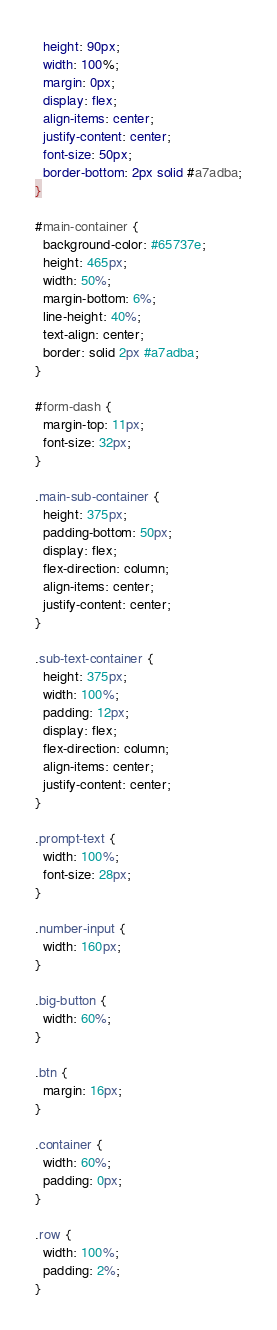Convert code to text. <code><loc_0><loc_0><loc_500><loc_500><_CSS_>  height: 90px;
  width: 100%;
  margin: 0px;
  display: flex;
  align-items: center;
  justify-content: center;
  font-size: 50px;
  border-bottom: 2px solid #a7adba;
}

#main-container {
  background-color: #65737e;
  height: 465px;
  width: 50%;
  margin-bottom: 6%;
  line-height: 40%;
  text-align: center;
  border: solid 2px #a7adba;
}

#form-dash {
  margin-top: 11px;
  font-size: 32px;
}

.main-sub-container {
  height: 375px;
  padding-bottom: 50px;
  display: flex;
  flex-direction: column;
  align-items: center;
  justify-content: center;
}

.sub-text-container {
  height: 375px;
  width: 100%;
  padding: 12px;
  display: flex;
  flex-direction: column;
  align-items: center;
  justify-content: center;
}

.prompt-text {
  width: 100%;
  font-size: 28px;
}

.number-input {
  width: 160px;
}

.big-button {
  width: 60%;
}

.btn {
  margin: 16px;
}

.container {
  width: 60%;
  padding: 0px;
}

.row {
  width: 100%;
  padding: 2%;
}

</code> 